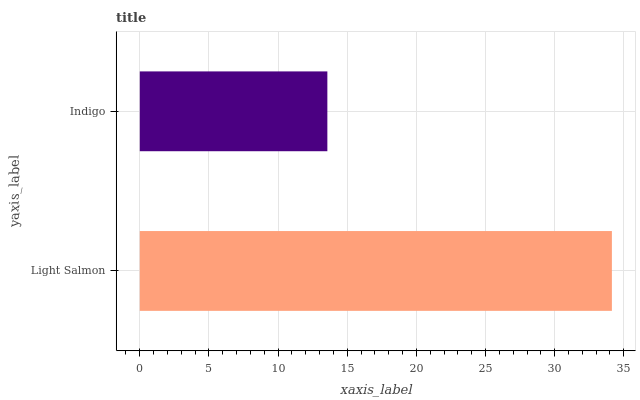Is Indigo the minimum?
Answer yes or no. Yes. Is Light Salmon the maximum?
Answer yes or no. Yes. Is Indigo the maximum?
Answer yes or no. No. Is Light Salmon greater than Indigo?
Answer yes or no. Yes. Is Indigo less than Light Salmon?
Answer yes or no. Yes. Is Indigo greater than Light Salmon?
Answer yes or no. No. Is Light Salmon less than Indigo?
Answer yes or no. No. Is Light Salmon the high median?
Answer yes or no. Yes. Is Indigo the low median?
Answer yes or no. Yes. Is Indigo the high median?
Answer yes or no. No. Is Light Salmon the low median?
Answer yes or no. No. 